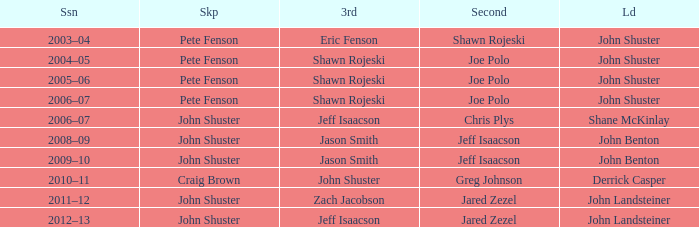Who was second when Shane McKinlay was the lead? Chris Plys. 